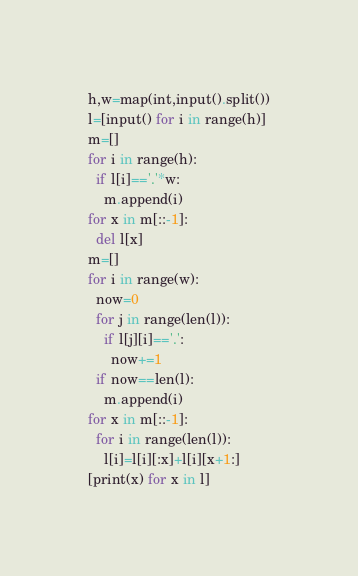Convert code to text. <code><loc_0><loc_0><loc_500><loc_500><_Python_>h,w=map(int,input().split())
l=[input() for i in range(h)]
m=[]
for i in range(h):
  if l[i]=='.'*w:
    m.append(i)
for x in m[::-1]:
  del l[x]
m=[]
for i in range(w):
  now=0
  for j in range(len(l)):
    if l[j][i]=='.':
      now+=1
  if now==len(l):
    m.append(i)
for x in m[::-1]:
  for i in range(len(l)):
    l[i]=l[i][:x]+l[i][x+1:]
[print(x) for x in l]</code> 